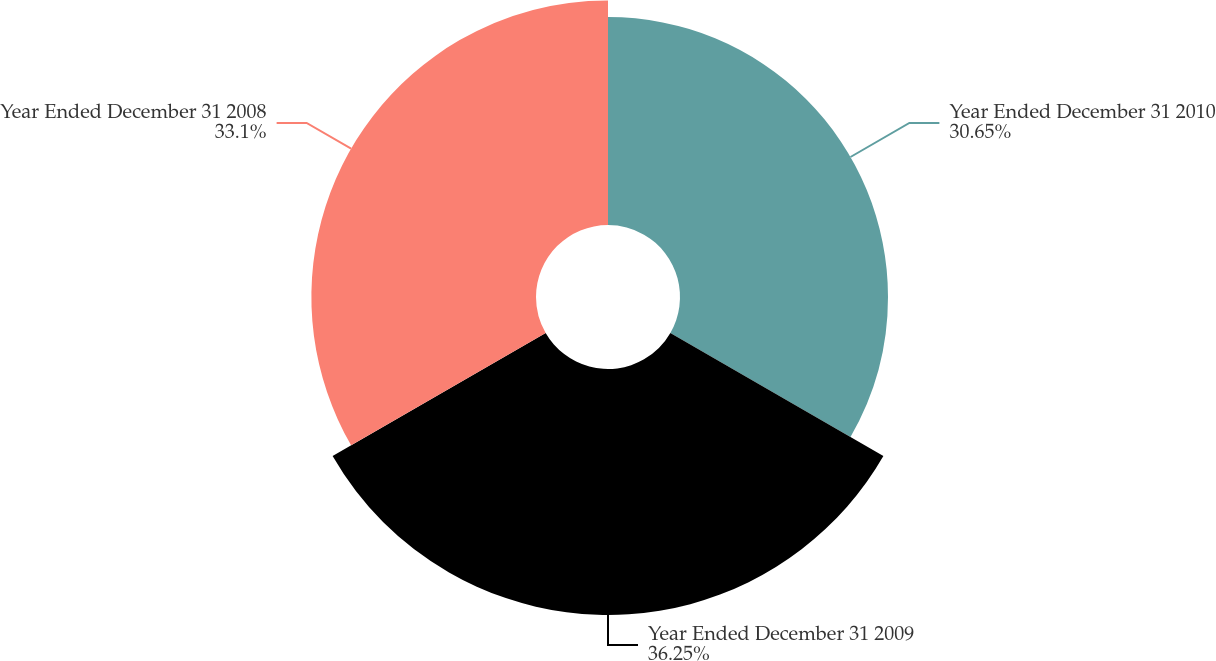Convert chart to OTSL. <chart><loc_0><loc_0><loc_500><loc_500><pie_chart><fcel>Year Ended December 31 2010<fcel>Year Ended December 31 2009<fcel>Year Ended December 31 2008<nl><fcel>30.65%<fcel>36.25%<fcel>33.1%<nl></chart> 